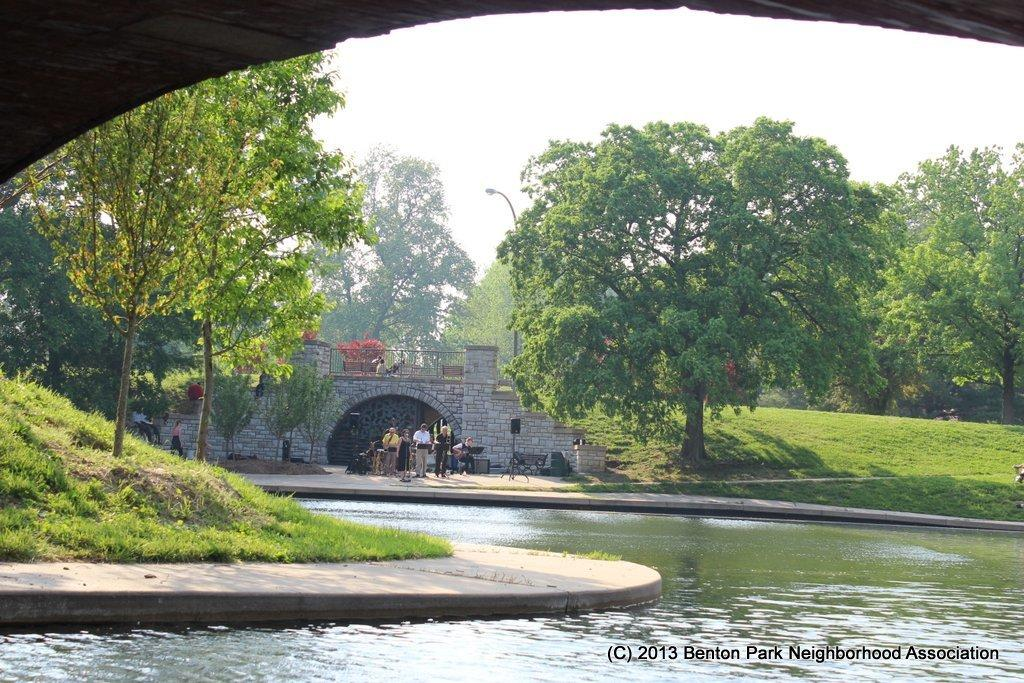What type of natural environment is visible in the image? Water, grass, and trees are visible in the image, indicating a natural environment. What type of man-made structure is present in the image? There is a bridge in the image. What type of lighting is present in the image? There is a street light in the image. What can be seen in the sky in the image? The sky is visible in the image. How many persons are present in the image? There are persons in the image. What is the opinion of the water in the image? The water in the image does not have an opinion, as it is an inanimate object. 